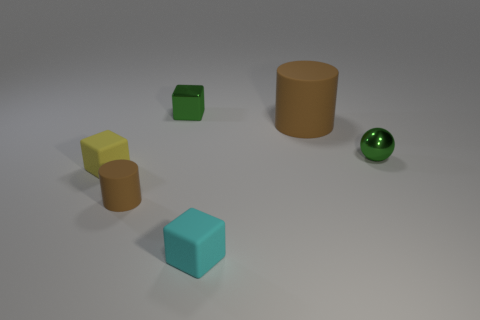Are there fewer matte things to the right of the small green metal sphere than tiny cylinders that are behind the tiny brown rubber cylinder?
Your answer should be compact. No. What number of things are metal cubes or tiny cyan rubber blocks?
Ensure brevity in your answer.  2. There is a tiny cyan thing; what number of green objects are on the left side of it?
Your response must be concise. 1. Is the color of the shiny ball the same as the small shiny block?
Give a very brief answer. Yes. What is the shape of the cyan thing that is the same material as the small yellow thing?
Make the answer very short. Cube. Is the shape of the tiny thing that is behind the small sphere the same as  the yellow rubber thing?
Offer a terse response. Yes. How many yellow things are cylinders or balls?
Keep it short and to the point. 0. Are there an equal number of small brown matte cylinders right of the tiny green shiny sphere and tiny rubber cylinders on the right side of the tiny matte cylinder?
Ensure brevity in your answer.  Yes. What is the color of the small shiny object in front of the cylinder that is to the right of the object that is in front of the tiny cylinder?
Offer a terse response. Green. Are there any other things of the same color as the big cylinder?
Offer a very short reply. Yes. 